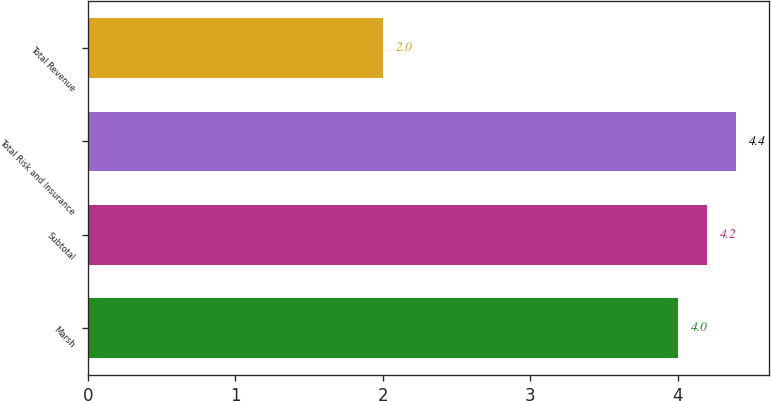Convert chart to OTSL. <chart><loc_0><loc_0><loc_500><loc_500><bar_chart><fcel>Marsh<fcel>Subtotal<fcel>Total Risk and Insurance<fcel>Total Revenue<nl><fcel>4<fcel>4.2<fcel>4.4<fcel>2<nl></chart> 